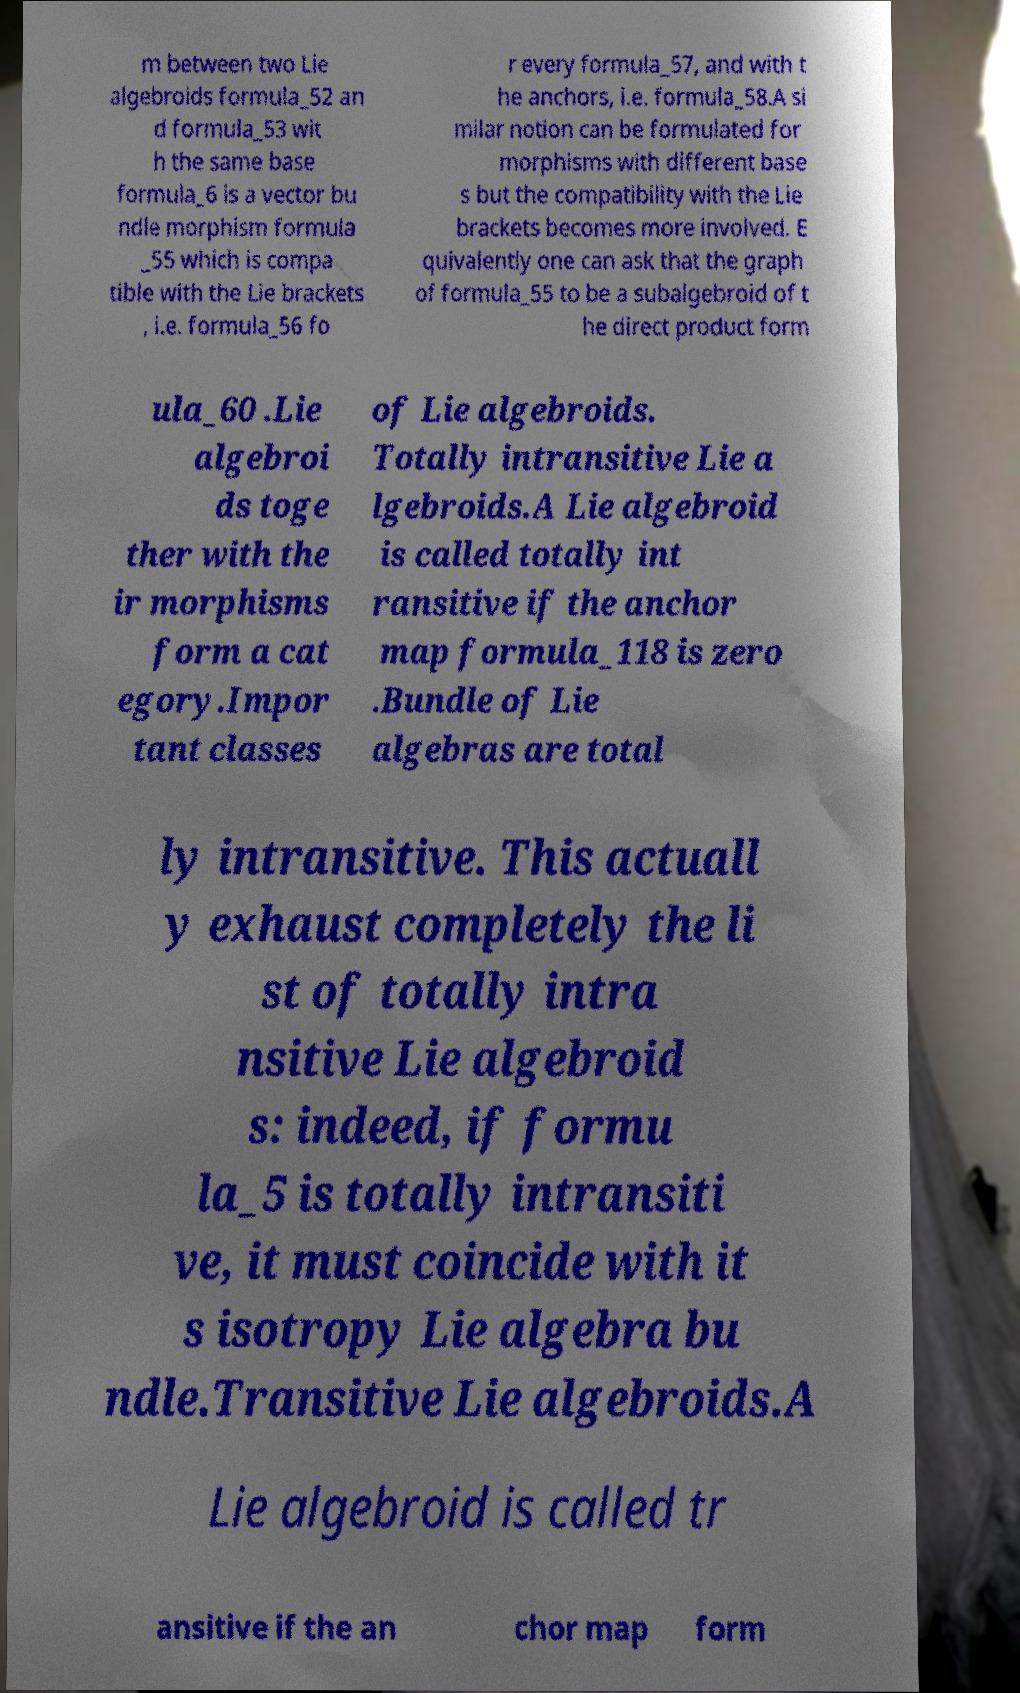What messages or text are displayed in this image? I need them in a readable, typed format. m between two Lie algebroids formula_52 an d formula_53 wit h the same base formula_6 is a vector bu ndle morphism formula _55 which is compa tible with the Lie brackets , i.e. formula_56 fo r every formula_57, and with t he anchors, i.e. formula_58.A si milar notion can be formulated for morphisms with different base s but the compatibility with the Lie brackets becomes more involved. E quivalently one can ask that the graph of formula_55 to be a subalgebroid of t he direct product form ula_60 .Lie algebroi ds toge ther with the ir morphisms form a cat egory.Impor tant classes of Lie algebroids. Totally intransitive Lie a lgebroids.A Lie algebroid is called totally int ransitive if the anchor map formula_118 is zero .Bundle of Lie algebras are total ly intransitive. This actuall y exhaust completely the li st of totally intra nsitive Lie algebroid s: indeed, if formu la_5 is totally intransiti ve, it must coincide with it s isotropy Lie algebra bu ndle.Transitive Lie algebroids.A Lie algebroid is called tr ansitive if the an chor map form 